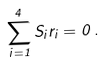Convert formula to latex. <formula><loc_0><loc_0><loc_500><loc_500>\sum _ { i = 1 } ^ { 4 } S _ { i } { r } _ { i } = { 0 } \, .</formula> 